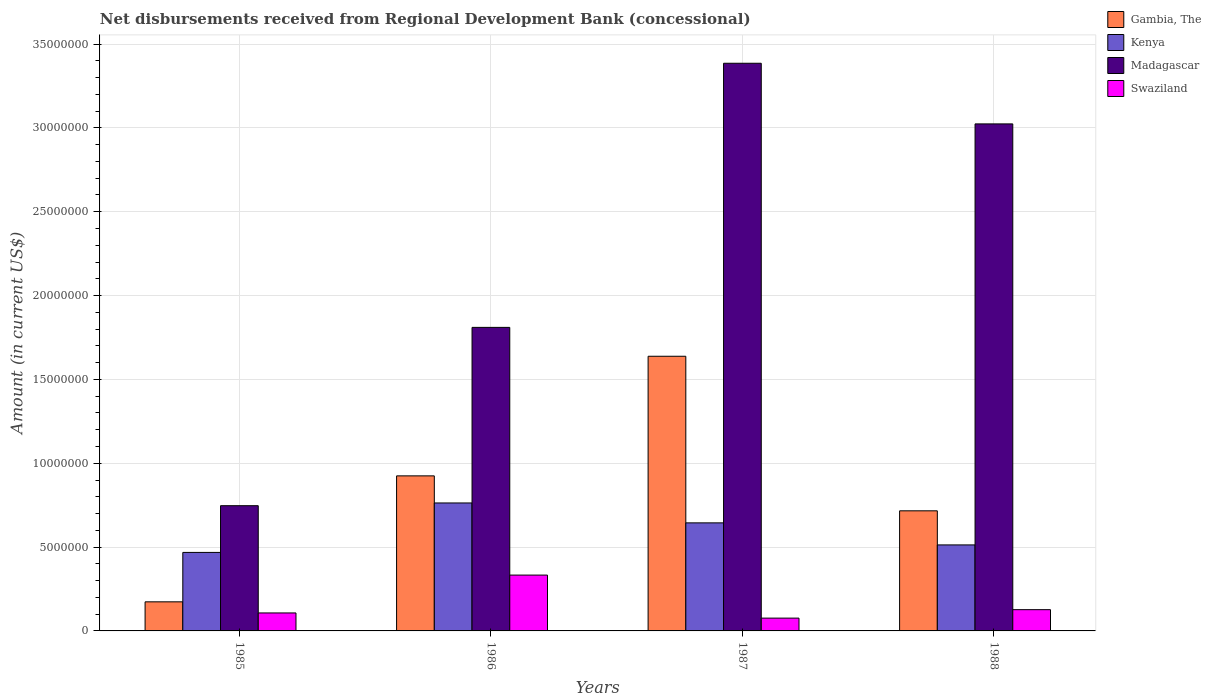How many different coloured bars are there?
Your answer should be very brief. 4. How many groups of bars are there?
Your response must be concise. 4. Are the number of bars on each tick of the X-axis equal?
Your answer should be very brief. Yes. How many bars are there on the 3rd tick from the right?
Provide a succinct answer. 4. What is the label of the 4th group of bars from the left?
Provide a short and direct response. 1988. What is the amount of disbursements received from Regional Development Bank in Madagascar in 1986?
Provide a succinct answer. 1.81e+07. Across all years, what is the maximum amount of disbursements received from Regional Development Bank in Swaziland?
Ensure brevity in your answer.  3.33e+06. Across all years, what is the minimum amount of disbursements received from Regional Development Bank in Madagascar?
Provide a short and direct response. 7.47e+06. What is the total amount of disbursements received from Regional Development Bank in Madagascar in the graph?
Offer a terse response. 8.97e+07. What is the difference between the amount of disbursements received from Regional Development Bank in Swaziland in 1985 and that in 1988?
Provide a short and direct response. -1.96e+05. What is the difference between the amount of disbursements received from Regional Development Bank in Gambia, The in 1987 and the amount of disbursements received from Regional Development Bank in Kenya in 1985?
Keep it short and to the point. 1.17e+07. What is the average amount of disbursements received from Regional Development Bank in Swaziland per year?
Your answer should be compact. 1.61e+06. In the year 1988, what is the difference between the amount of disbursements received from Regional Development Bank in Madagascar and amount of disbursements received from Regional Development Bank in Kenya?
Give a very brief answer. 2.51e+07. In how many years, is the amount of disbursements received from Regional Development Bank in Swaziland greater than 14000000 US$?
Your answer should be very brief. 0. What is the ratio of the amount of disbursements received from Regional Development Bank in Madagascar in 1986 to that in 1987?
Give a very brief answer. 0.53. Is the difference between the amount of disbursements received from Regional Development Bank in Madagascar in 1986 and 1987 greater than the difference between the amount of disbursements received from Regional Development Bank in Kenya in 1986 and 1987?
Ensure brevity in your answer.  No. What is the difference between the highest and the second highest amount of disbursements received from Regional Development Bank in Madagascar?
Make the answer very short. 3.62e+06. What is the difference between the highest and the lowest amount of disbursements received from Regional Development Bank in Madagascar?
Your answer should be compact. 2.64e+07. In how many years, is the amount of disbursements received from Regional Development Bank in Gambia, The greater than the average amount of disbursements received from Regional Development Bank in Gambia, The taken over all years?
Keep it short and to the point. 2. What does the 3rd bar from the left in 1987 represents?
Your response must be concise. Madagascar. What does the 3rd bar from the right in 1985 represents?
Provide a short and direct response. Kenya. Is it the case that in every year, the sum of the amount of disbursements received from Regional Development Bank in Gambia, The and amount of disbursements received from Regional Development Bank in Swaziland is greater than the amount of disbursements received from Regional Development Bank in Madagascar?
Offer a terse response. No. How many bars are there?
Your response must be concise. 16. How many years are there in the graph?
Provide a short and direct response. 4. Are the values on the major ticks of Y-axis written in scientific E-notation?
Ensure brevity in your answer.  No. Where does the legend appear in the graph?
Offer a terse response. Top right. How many legend labels are there?
Make the answer very short. 4. What is the title of the graph?
Your answer should be compact. Net disbursements received from Regional Development Bank (concessional). Does "Euro area" appear as one of the legend labels in the graph?
Your response must be concise. No. What is the label or title of the Y-axis?
Make the answer very short. Amount (in current US$). What is the Amount (in current US$) in Gambia, The in 1985?
Your answer should be very brief. 1.74e+06. What is the Amount (in current US$) of Kenya in 1985?
Provide a short and direct response. 4.68e+06. What is the Amount (in current US$) in Madagascar in 1985?
Keep it short and to the point. 7.47e+06. What is the Amount (in current US$) of Swaziland in 1985?
Provide a succinct answer. 1.07e+06. What is the Amount (in current US$) in Gambia, The in 1986?
Provide a short and direct response. 9.25e+06. What is the Amount (in current US$) of Kenya in 1986?
Give a very brief answer. 7.63e+06. What is the Amount (in current US$) in Madagascar in 1986?
Your response must be concise. 1.81e+07. What is the Amount (in current US$) of Swaziland in 1986?
Give a very brief answer. 3.33e+06. What is the Amount (in current US$) of Gambia, The in 1987?
Offer a terse response. 1.64e+07. What is the Amount (in current US$) of Kenya in 1987?
Your answer should be compact. 6.44e+06. What is the Amount (in current US$) in Madagascar in 1987?
Your response must be concise. 3.39e+07. What is the Amount (in current US$) in Swaziland in 1987?
Make the answer very short. 7.64e+05. What is the Amount (in current US$) of Gambia, The in 1988?
Your answer should be very brief. 7.16e+06. What is the Amount (in current US$) of Kenya in 1988?
Ensure brevity in your answer.  5.13e+06. What is the Amount (in current US$) in Madagascar in 1988?
Offer a very short reply. 3.02e+07. What is the Amount (in current US$) in Swaziland in 1988?
Provide a short and direct response. 1.27e+06. Across all years, what is the maximum Amount (in current US$) in Gambia, The?
Make the answer very short. 1.64e+07. Across all years, what is the maximum Amount (in current US$) in Kenya?
Provide a short and direct response. 7.63e+06. Across all years, what is the maximum Amount (in current US$) of Madagascar?
Give a very brief answer. 3.39e+07. Across all years, what is the maximum Amount (in current US$) of Swaziland?
Keep it short and to the point. 3.33e+06. Across all years, what is the minimum Amount (in current US$) in Gambia, The?
Provide a short and direct response. 1.74e+06. Across all years, what is the minimum Amount (in current US$) in Kenya?
Offer a terse response. 4.68e+06. Across all years, what is the minimum Amount (in current US$) in Madagascar?
Provide a succinct answer. 7.47e+06. Across all years, what is the minimum Amount (in current US$) of Swaziland?
Provide a succinct answer. 7.64e+05. What is the total Amount (in current US$) in Gambia, The in the graph?
Your answer should be very brief. 3.45e+07. What is the total Amount (in current US$) of Kenya in the graph?
Make the answer very short. 2.39e+07. What is the total Amount (in current US$) of Madagascar in the graph?
Make the answer very short. 8.97e+07. What is the total Amount (in current US$) of Swaziland in the graph?
Provide a succinct answer. 6.43e+06. What is the difference between the Amount (in current US$) in Gambia, The in 1985 and that in 1986?
Your response must be concise. -7.51e+06. What is the difference between the Amount (in current US$) of Kenya in 1985 and that in 1986?
Give a very brief answer. -2.95e+06. What is the difference between the Amount (in current US$) of Madagascar in 1985 and that in 1986?
Your answer should be compact. -1.06e+07. What is the difference between the Amount (in current US$) in Swaziland in 1985 and that in 1986?
Ensure brevity in your answer.  -2.26e+06. What is the difference between the Amount (in current US$) in Gambia, The in 1985 and that in 1987?
Provide a short and direct response. -1.46e+07. What is the difference between the Amount (in current US$) in Kenya in 1985 and that in 1987?
Your answer should be very brief. -1.76e+06. What is the difference between the Amount (in current US$) in Madagascar in 1985 and that in 1987?
Give a very brief answer. -2.64e+07. What is the difference between the Amount (in current US$) in Swaziland in 1985 and that in 1987?
Your response must be concise. 3.08e+05. What is the difference between the Amount (in current US$) in Gambia, The in 1985 and that in 1988?
Provide a short and direct response. -5.43e+06. What is the difference between the Amount (in current US$) in Kenya in 1985 and that in 1988?
Keep it short and to the point. -4.48e+05. What is the difference between the Amount (in current US$) of Madagascar in 1985 and that in 1988?
Keep it short and to the point. -2.28e+07. What is the difference between the Amount (in current US$) in Swaziland in 1985 and that in 1988?
Make the answer very short. -1.96e+05. What is the difference between the Amount (in current US$) in Gambia, The in 1986 and that in 1987?
Make the answer very short. -7.13e+06. What is the difference between the Amount (in current US$) in Kenya in 1986 and that in 1987?
Keep it short and to the point. 1.19e+06. What is the difference between the Amount (in current US$) of Madagascar in 1986 and that in 1987?
Your answer should be compact. -1.58e+07. What is the difference between the Amount (in current US$) in Swaziland in 1986 and that in 1987?
Give a very brief answer. 2.57e+06. What is the difference between the Amount (in current US$) in Gambia, The in 1986 and that in 1988?
Offer a terse response. 2.08e+06. What is the difference between the Amount (in current US$) in Kenya in 1986 and that in 1988?
Your response must be concise. 2.50e+06. What is the difference between the Amount (in current US$) of Madagascar in 1986 and that in 1988?
Keep it short and to the point. -1.21e+07. What is the difference between the Amount (in current US$) of Swaziland in 1986 and that in 1988?
Offer a terse response. 2.06e+06. What is the difference between the Amount (in current US$) of Gambia, The in 1987 and that in 1988?
Your answer should be very brief. 9.22e+06. What is the difference between the Amount (in current US$) of Kenya in 1987 and that in 1988?
Make the answer very short. 1.32e+06. What is the difference between the Amount (in current US$) of Madagascar in 1987 and that in 1988?
Your answer should be very brief. 3.62e+06. What is the difference between the Amount (in current US$) of Swaziland in 1987 and that in 1988?
Give a very brief answer. -5.04e+05. What is the difference between the Amount (in current US$) of Gambia, The in 1985 and the Amount (in current US$) of Kenya in 1986?
Your response must be concise. -5.90e+06. What is the difference between the Amount (in current US$) in Gambia, The in 1985 and the Amount (in current US$) in Madagascar in 1986?
Provide a succinct answer. -1.64e+07. What is the difference between the Amount (in current US$) of Gambia, The in 1985 and the Amount (in current US$) of Swaziland in 1986?
Give a very brief answer. -1.60e+06. What is the difference between the Amount (in current US$) of Kenya in 1985 and the Amount (in current US$) of Madagascar in 1986?
Provide a succinct answer. -1.34e+07. What is the difference between the Amount (in current US$) of Kenya in 1985 and the Amount (in current US$) of Swaziland in 1986?
Make the answer very short. 1.35e+06. What is the difference between the Amount (in current US$) in Madagascar in 1985 and the Amount (in current US$) in Swaziland in 1986?
Provide a succinct answer. 4.14e+06. What is the difference between the Amount (in current US$) of Gambia, The in 1985 and the Amount (in current US$) of Kenya in 1987?
Keep it short and to the point. -4.71e+06. What is the difference between the Amount (in current US$) of Gambia, The in 1985 and the Amount (in current US$) of Madagascar in 1987?
Your response must be concise. -3.21e+07. What is the difference between the Amount (in current US$) of Gambia, The in 1985 and the Amount (in current US$) of Swaziland in 1987?
Keep it short and to the point. 9.71e+05. What is the difference between the Amount (in current US$) of Kenya in 1985 and the Amount (in current US$) of Madagascar in 1987?
Keep it short and to the point. -2.92e+07. What is the difference between the Amount (in current US$) of Kenya in 1985 and the Amount (in current US$) of Swaziland in 1987?
Give a very brief answer. 3.92e+06. What is the difference between the Amount (in current US$) in Madagascar in 1985 and the Amount (in current US$) in Swaziland in 1987?
Offer a very short reply. 6.70e+06. What is the difference between the Amount (in current US$) of Gambia, The in 1985 and the Amount (in current US$) of Kenya in 1988?
Give a very brief answer. -3.40e+06. What is the difference between the Amount (in current US$) of Gambia, The in 1985 and the Amount (in current US$) of Madagascar in 1988?
Provide a short and direct response. -2.85e+07. What is the difference between the Amount (in current US$) of Gambia, The in 1985 and the Amount (in current US$) of Swaziland in 1988?
Provide a short and direct response. 4.67e+05. What is the difference between the Amount (in current US$) of Kenya in 1985 and the Amount (in current US$) of Madagascar in 1988?
Keep it short and to the point. -2.56e+07. What is the difference between the Amount (in current US$) in Kenya in 1985 and the Amount (in current US$) in Swaziland in 1988?
Ensure brevity in your answer.  3.41e+06. What is the difference between the Amount (in current US$) of Madagascar in 1985 and the Amount (in current US$) of Swaziland in 1988?
Give a very brief answer. 6.20e+06. What is the difference between the Amount (in current US$) of Gambia, The in 1986 and the Amount (in current US$) of Kenya in 1987?
Give a very brief answer. 2.80e+06. What is the difference between the Amount (in current US$) of Gambia, The in 1986 and the Amount (in current US$) of Madagascar in 1987?
Provide a succinct answer. -2.46e+07. What is the difference between the Amount (in current US$) in Gambia, The in 1986 and the Amount (in current US$) in Swaziland in 1987?
Your answer should be very brief. 8.48e+06. What is the difference between the Amount (in current US$) in Kenya in 1986 and the Amount (in current US$) in Madagascar in 1987?
Ensure brevity in your answer.  -2.62e+07. What is the difference between the Amount (in current US$) in Kenya in 1986 and the Amount (in current US$) in Swaziland in 1987?
Provide a succinct answer. 6.87e+06. What is the difference between the Amount (in current US$) of Madagascar in 1986 and the Amount (in current US$) of Swaziland in 1987?
Give a very brief answer. 1.73e+07. What is the difference between the Amount (in current US$) in Gambia, The in 1986 and the Amount (in current US$) in Kenya in 1988?
Your answer should be very brief. 4.12e+06. What is the difference between the Amount (in current US$) in Gambia, The in 1986 and the Amount (in current US$) in Madagascar in 1988?
Your answer should be compact. -2.10e+07. What is the difference between the Amount (in current US$) of Gambia, The in 1986 and the Amount (in current US$) of Swaziland in 1988?
Your response must be concise. 7.98e+06. What is the difference between the Amount (in current US$) in Kenya in 1986 and the Amount (in current US$) in Madagascar in 1988?
Give a very brief answer. -2.26e+07. What is the difference between the Amount (in current US$) in Kenya in 1986 and the Amount (in current US$) in Swaziland in 1988?
Ensure brevity in your answer.  6.36e+06. What is the difference between the Amount (in current US$) in Madagascar in 1986 and the Amount (in current US$) in Swaziland in 1988?
Your answer should be very brief. 1.68e+07. What is the difference between the Amount (in current US$) in Gambia, The in 1987 and the Amount (in current US$) in Kenya in 1988?
Offer a very short reply. 1.13e+07. What is the difference between the Amount (in current US$) of Gambia, The in 1987 and the Amount (in current US$) of Madagascar in 1988?
Keep it short and to the point. -1.39e+07. What is the difference between the Amount (in current US$) of Gambia, The in 1987 and the Amount (in current US$) of Swaziland in 1988?
Provide a succinct answer. 1.51e+07. What is the difference between the Amount (in current US$) in Kenya in 1987 and the Amount (in current US$) in Madagascar in 1988?
Make the answer very short. -2.38e+07. What is the difference between the Amount (in current US$) in Kenya in 1987 and the Amount (in current US$) in Swaziland in 1988?
Your answer should be very brief. 5.18e+06. What is the difference between the Amount (in current US$) in Madagascar in 1987 and the Amount (in current US$) in Swaziland in 1988?
Give a very brief answer. 3.26e+07. What is the average Amount (in current US$) of Gambia, The per year?
Your response must be concise. 8.63e+06. What is the average Amount (in current US$) in Kenya per year?
Offer a very short reply. 5.97e+06. What is the average Amount (in current US$) in Madagascar per year?
Your answer should be very brief. 2.24e+07. What is the average Amount (in current US$) in Swaziland per year?
Keep it short and to the point. 1.61e+06. In the year 1985, what is the difference between the Amount (in current US$) in Gambia, The and Amount (in current US$) in Kenya?
Offer a terse response. -2.95e+06. In the year 1985, what is the difference between the Amount (in current US$) of Gambia, The and Amount (in current US$) of Madagascar?
Ensure brevity in your answer.  -5.73e+06. In the year 1985, what is the difference between the Amount (in current US$) in Gambia, The and Amount (in current US$) in Swaziland?
Offer a terse response. 6.63e+05. In the year 1985, what is the difference between the Amount (in current US$) in Kenya and Amount (in current US$) in Madagascar?
Offer a terse response. -2.79e+06. In the year 1985, what is the difference between the Amount (in current US$) in Kenya and Amount (in current US$) in Swaziland?
Your answer should be very brief. 3.61e+06. In the year 1985, what is the difference between the Amount (in current US$) of Madagascar and Amount (in current US$) of Swaziland?
Your response must be concise. 6.40e+06. In the year 1986, what is the difference between the Amount (in current US$) in Gambia, The and Amount (in current US$) in Kenya?
Provide a short and direct response. 1.62e+06. In the year 1986, what is the difference between the Amount (in current US$) of Gambia, The and Amount (in current US$) of Madagascar?
Offer a terse response. -8.86e+06. In the year 1986, what is the difference between the Amount (in current US$) of Gambia, The and Amount (in current US$) of Swaziland?
Your answer should be compact. 5.92e+06. In the year 1986, what is the difference between the Amount (in current US$) of Kenya and Amount (in current US$) of Madagascar?
Ensure brevity in your answer.  -1.05e+07. In the year 1986, what is the difference between the Amount (in current US$) of Kenya and Amount (in current US$) of Swaziland?
Your response must be concise. 4.30e+06. In the year 1986, what is the difference between the Amount (in current US$) in Madagascar and Amount (in current US$) in Swaziland?
Keep it short and to the point. 1.48e+07. In the year 1987, what is the difference between the Amount (in current US$) of Gambia, The and Amount (in current US$) of Kenya?
Give a very brief answer. 9.94e+06. In the year 1987, what is the difference between the Amount (in current US$) of Gambia, The and Amount (in current US$) of Madagascar?
Offer a terse response. -1.75e+07. In the year 1987, what is the difference between the Amount (in current US$) in Gambia, The and Amount (in current US$) in Swaziland?
Keep it short and to the point. 1.56e+07. In the year 1987, what is the difference between the Amount (in current US$) of Kenya and Amount (in current US$) of Madagascar?
Offer a terse response. -2.74e+07. In the year 1987, what is the difference between the Amount (in current US$) in Kenya and Amount (in current US$) in Swaziland?
Provide a succinct answer. 5.68e+06. In the year 1987, what is the difference between the Amount (in current US$) in Madagascar and Amount (in current US$) in Swaziland?
Keep it short and to the point. 3.31e+07. In the year 1988, what is the difference between the Amount (in current US$) of Gambia, The and Amount (in current US$) of Kenya?
Ensure brevity in your answer.  2.03e+06. In the year 1988, what is the difference between the Amount (in current US$) of Gambia, The and Amount (in current US$) of Madagascar?
Ensure brevity in your answer.  -2.31e+07. In the year 1988, what is the difference between the Amount (in current US$) in Gambia, The and Amount (in current US$) in Swaziland?
Offer a very short reply. 5.90e+06. In the year 1988, what is the difference between the Amount (in current US$) in Kenya and Amount (in current US$) in Madagascar?
Give a very brief answer. -2.51e+07. In the year 1988, what is the difference between the Amount (in current US$) in Kenya and Amount (in current US$) in Swaziland?
Offer a terse response. 3.86e+06. In the year 1988, what is the difference between the Amount (in current US$) of Madagascar and Amount (in current US$) of Swaziland?
Offer a very short reply. 2.90e+07. What is the ratio of the Amount (in current US$) in Gambia, The in 1985 to that in 1986?
Offer a terse response. 0.19. What is the ratio of the Amount (in current US$) in Kenya in 1985 to that in 1986?
Offer a terse response. 0.61. What is the ratio of the Amount (in current US$) of Madagascar in 1985 to that in 1986?
Your answer should be compact. 0.41. What is the ratio of the Amount (in current US$) of Swaziland in 1985 to that in 1986?
Provide a short and direct response. 0.32. What is the ratio of the Amount (in current US$) of Gambia, The in 1985 to that in 1987?
Ensure brevity in your answer.  0.11. What is the ratio of the Amount (in current US$) of Kenya in 1985 to that in 1987?
Your answer should be very brief. 0.73. What is the ratio of the Amount (in current US$) in Madagascar in 1985 to that in 1987?
Your answer should be very brief. 0.22. What is the ratio of the Amount (in current US$) of Swaziland in 1985 to that in 1987?
Provide a short and direct response. 1.4. What is the ratio of the Amount (in current US$) in Gambia, The in 1985 to that in 1988?
Your answer should be very brief. 0.24. What is the ratio of the Amount (in current US$) in Kenya in 1985 to that in 1988?
Provide a short and direct response. 0.91. What is the ratio of the Amount (in current US$) of Madagascar in 1985 to that in 1988?
Provide a short and direct response. 0.25. What is the ratio of the Amount (in current US$) in Swaziland in 1985 to that in 1988?
Provide a short and direct response. 0.85. What is the ratio of the Amount (in current US$) in Gambia, The in 1986 to that in 1987?
Ensure brevity in your answer.  0.56. What is the ratio of the Amount (in current US$) of Kenya in 1986 to that in 1987?
Offer a very short reply. 1.18. What is the ratio of the Amount (in current US$) of Madagascar in 1986 to that in 1987?
Your answer should be very brief. 0.53. What is the ratio of the Amount (in current US$) in Swaziland in 1986 to that in 1987?
Your response must be concise. 4.36. What is the ratio of the Amount (in current US$) of Gambia, The in 1986 to that in 1988?
Your answer should be compact. 1.29. What is the ratio of the Amount (in current US$) in Kenya in 1986 to that in 1988?
Provide a succinct answer. 1.49. What is the ratio of the Amount (in current US$) in Madagascar in 1986 to that in 1988?
Your answer should be very brief. 0.6. What is the ratio of the Amount (in current US$) of Swaziland in 1986 to that in 1988?
Keep it short and to the point. 2.63. What is the ratio of the Amount (in current US$) in Gambia, The in 1987 to that in 1988?
Provide a succinct answer. 2.29. What is the ratio of the Amount (in current US$) of Kenya in 1987 to that in 1988?
Give a very brief answer. 1.26. What is the ratio of the Amount (in current US$) of Madagascar in 1987 to that in 1988?
Provide a succinct answer. 1.12. What is the ratio of the Amount (in current US$) of Swaziland in 1987 to that in 1988?
Keep it short and to the point. 0.6. What is the difference between the highest and the second highest Amount (in current US$) of Gambia, The?
Your response must be concise. 7.13e+06. What is the difference between the highest and the second highest Amount (in current US$) in Kenya?
Your answer should be very brief. 1.19e+06. What is the difference between the highest and the second highest Amount (in current US$) in Madagascar?
Offer a very short reply. 3.62e+06. What is the difference between the highest and the second highest Amount (in current US$) in Swaziland?
Offer a terse response. 2.06e+06. What is the difference between the highest and the lowest Amount (in current US$) in Gambia, The?
Provide a succinct answer. 1.46e+07. What is the difference between the highest and the lowest Amount (in current US$) in Kenya?
Make the answer very short. 2.95e+06. What is the difference between the highest and the lowest Amount (in current US$) of Madagascar?
Your answer should be very brief. 2.64e+07. What is the difference between the highest and the lowest Amount (in current US$) of Swaziland?
Your answer should be compact. 2.57e+06. 